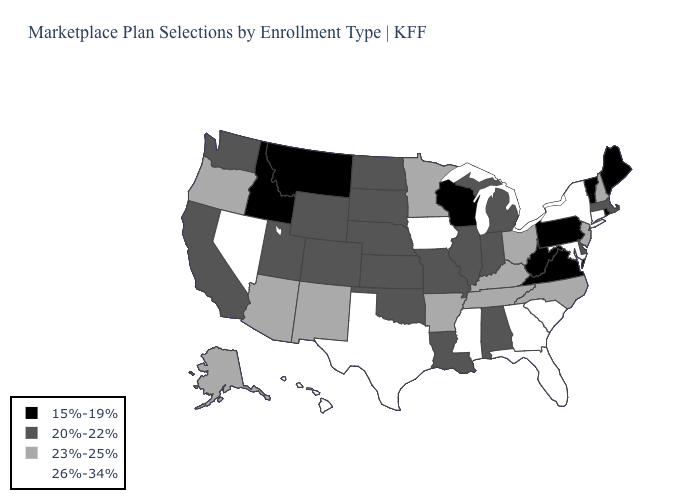Name the states that have a value in the range 26%-34%?
Keep it brief. Connecticut, Florida, Georgia, Hawaii, Iowa, Maryland, Mississippi, Nevada, New York, South Carolina, Texas. Name the states that have a value in the range 20%-22%?
Quick response, please. Alabama, California, Colorado, Delaware, Illinois, Indiana, Kansas, Louisiana, Massachusetts, Michigan, Missouri, Nebraska, North Dakota, Oklahoma, South Dakota, Utah, Washington, Wyoming. Does the map have missing data?
Be succinct. No. Does Mississippi have the highest value in the USA?
Write a very short answer. Yes. Among the states that border Missouri , does Tennessee have the highest value?
Give a very brief answer. No. What is the value of Idaho?
Quick response, please. 15%-19%. Among the states that border Arizona , which have the lowest value?
Write a very short answer. California, Colorado, Utah. Name the states that have a value in the range 20%-22%?
Give a very brief answer. Alabama, California, Colorado, Delaware, Illinois, Indiana, Kansas, Louisiana, Massachusetts, Michigan, Missouri, Nebraska, North Dakota, Oklahoma, South Dakota, Utah, Washington, Wyoming. Name the states that have a value in the range 20%-22%?
Short answer required. Alabama, California, Colorado, Delaware, Illinois, Indiana, Kansas, Louisiana, Massachusetts, Michigan, Missouri, Nebraska, North Dakota, Oklahoma, South Dakota, Utah, Washington, Wyoming. Name the states that have a value in the range 20%-22%?
Write a very short answer. Alabama, California, Colorado, Delaware, Illinois, Indiana, Kansas, Louisiana, Massachusetts, Michigan, Missouri, Nebraska, North Dakota, Oklahoma, South Dakota, Utah, Washington, Wyoming. Name the states that have a value in the range 15%-19%?
Be succinct. Idaho, Maine, Montana, Pennsylvania, Rhode Island, Vermont, Virginia, West Virginia, Wisconsin. Among the states that border Washington , which have the highest value?
Answer briefly. Oregon. Which states have the lowest value in the Northeast?
Be succinct. Maine, Pennsylvania, Rhode Island, Vermont. Which states have the highest value in the USA?
Concise answer only. Connecticut, Florida, Georgia, Hawaii, Iowa, Maryland, Mississippi, Nevada, New York, South Carolina, Texas. Among the states that border Tennessee , which have the highest value?
Quick response, please. Georgia, Mississippi. 